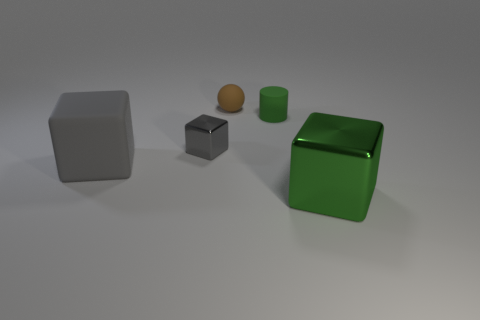Are there more small brown matte objects that are in front of the big gray matte cube than big green matte cylinders? After reviewing the image, it appears that there are equal numbers of small brown matte objects in front of the big gray matte cube and big green matte cylinders, which is one each. 